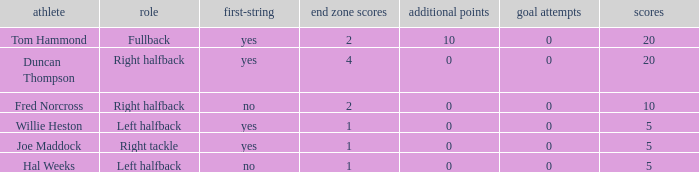What is the highest field goals when there were more than 1 touchdown and 0 extra points? 0.0. 